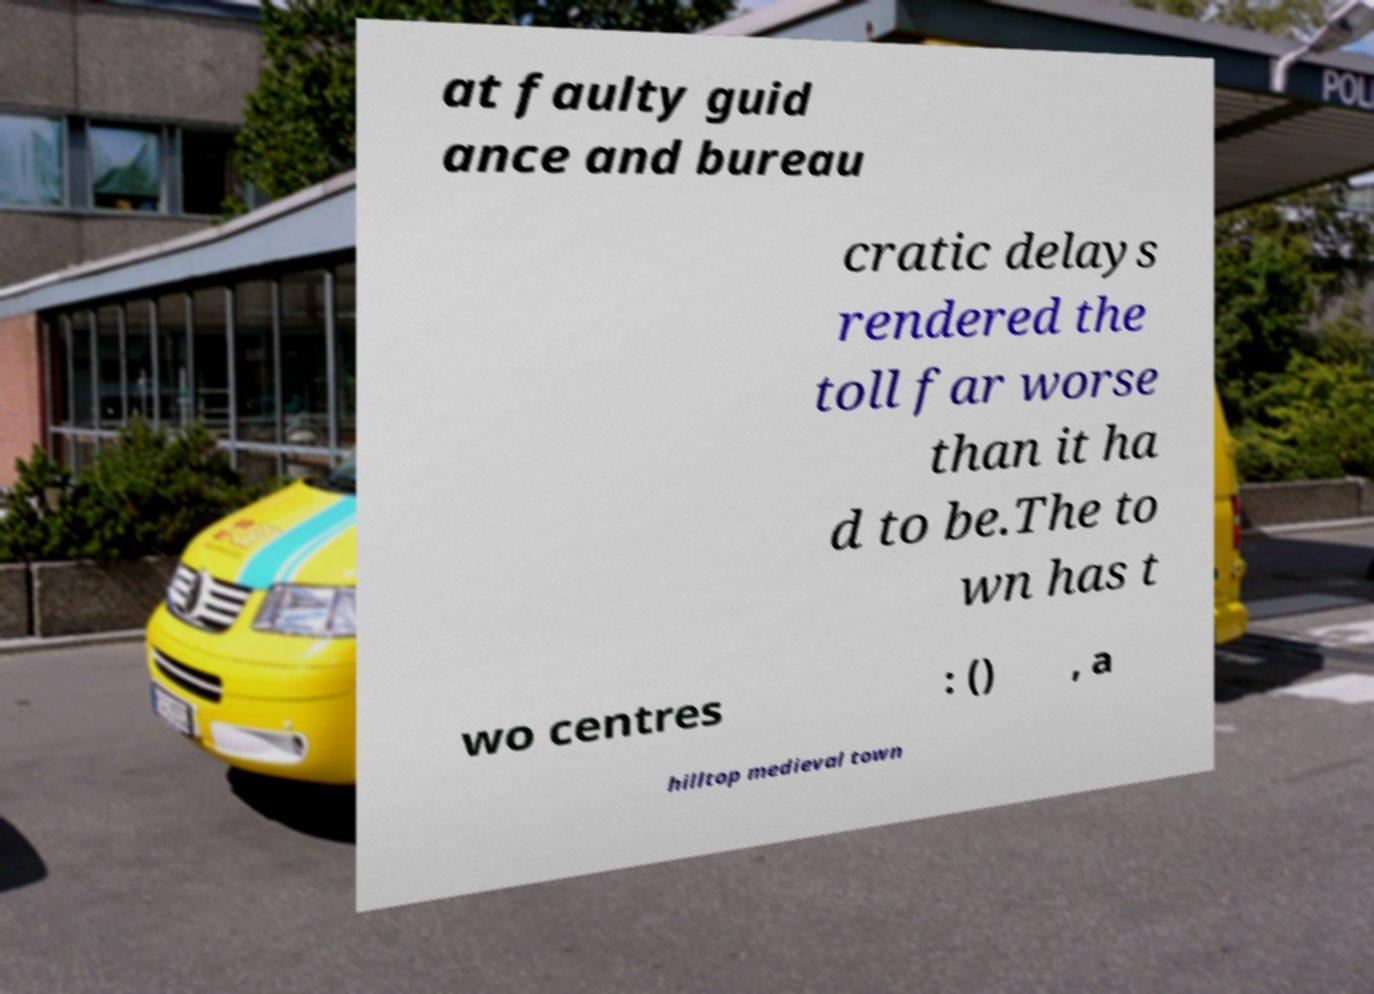For documentation purposes, I need the text within this image transcribed. Could you provide that? at faulty guid ance and bureau cratic delays rendered the toll far worse than it ha d to be.The to wn has t wo centres : () , a hilltop medieval town 